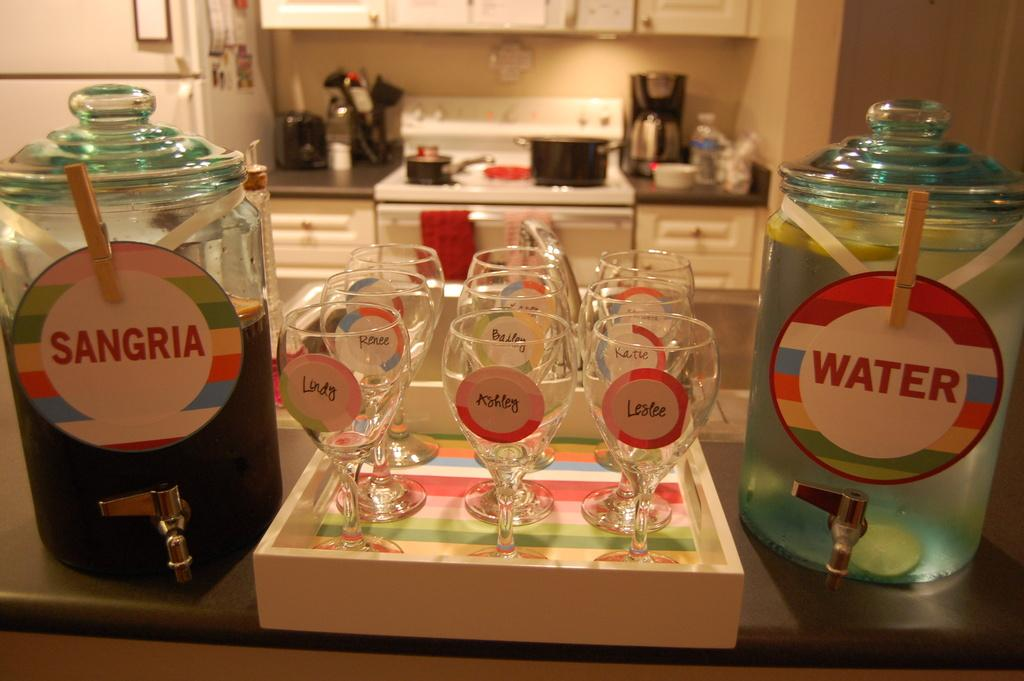Provide a one-sentence caption for the provided image. a few pitchers of Sangria and water and glasses with girls names on them. 